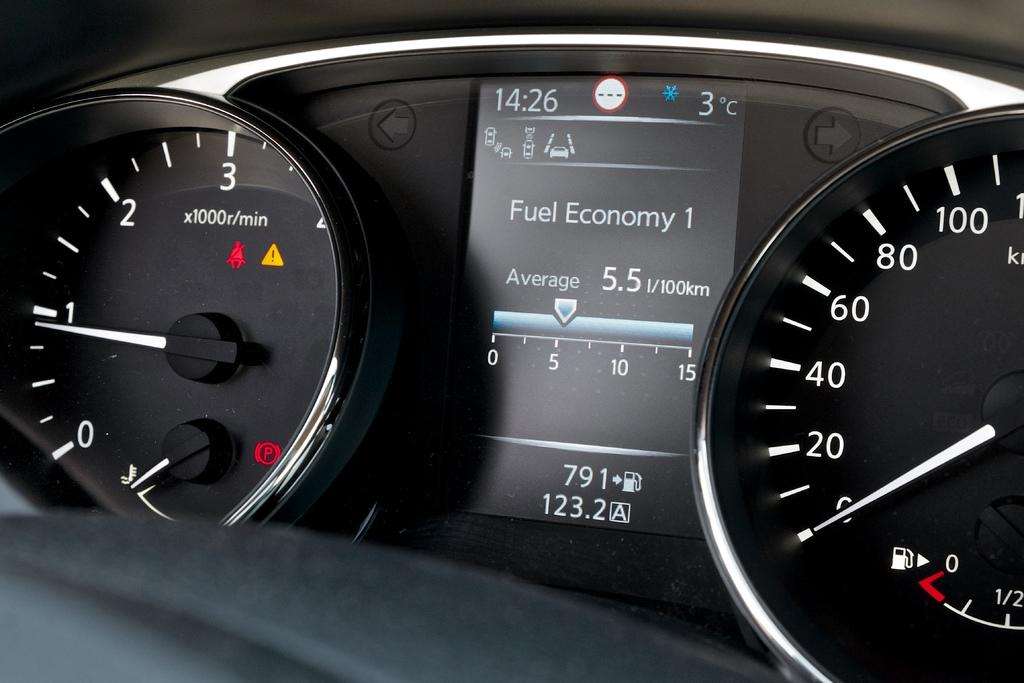What is the main object in the image? There is a speedometer in the image. What can be said about the color of the speedometer? The speedometer is in black and white color. What type of list can be seen in the image? There is no list present in the image; it only features a black and white speedometer. 